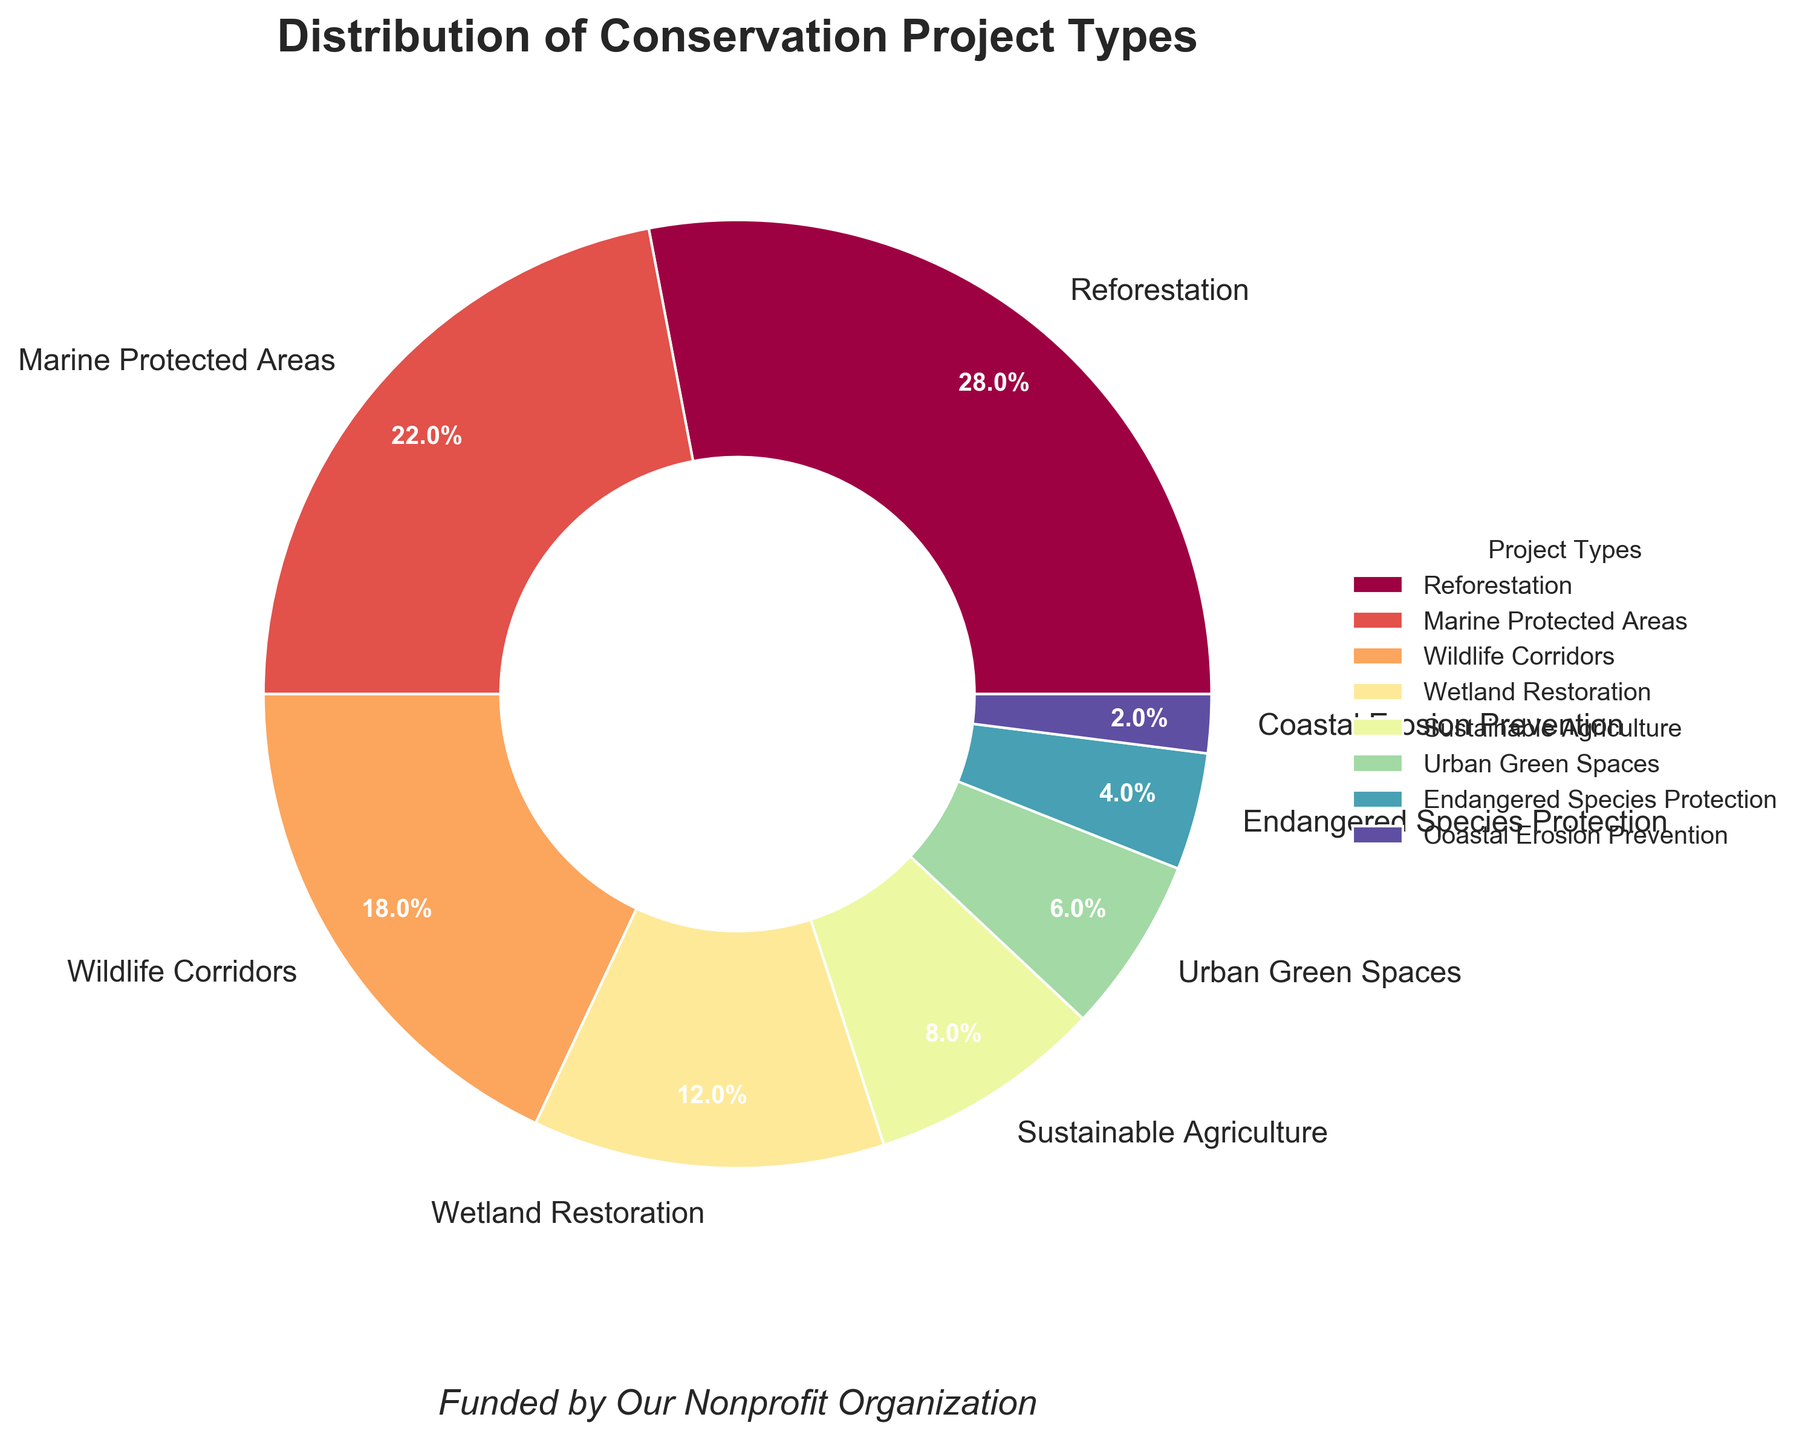What percentage of projects funded are focused on marine conservation (i.e., Marine Protected Areas and Coastal Erosion Prevention combined)? Add the percentages of Marine Protected Areas and Coastal Erosion Prevention: 22% + 2% = 24%
Answer: 24% Which project type has the lowest percentage of funding? The project type with the smallest wedge in the pie chart represents the lowest percentage, which is Coastal Erosion Prevention at 2%
Answer: Coastal Erosion Prevention How much higher is the percentage of Reforestation projects than Sustainable Agriculture projects? Subtract the percentage of Sustainable Agriculture from that of Reforestation: 28% - 8% = 20%
Answer: 20% What is the combined percentage of projects focused on land conservation (i.e., Reforestation, Wildlife Corridors, and Urban Green Spaces)? Sum the percentages: 28% (Reforestation) + 18% (Wildlife Corridors) + 6% (Urban Green Spaces) = 52%
Answer: 52% Which has a higher percentage, Wetland Restoration or Endangered Species Protection? Compare the percentages: Wetland Restoration is 12%, and Endangered Species Protection is 4%, so Wetland Restoration is higher
Answer: Wetland Restoration How much lower is the percentage of Endangered Species Protection compared to Wildlife Corridors? Subtract the percentage of Endangered Species Protection from that of Wildlife Corridors: 18% - 4% = 14%
Answer: 14% If you consider only projects related to terrestrial ecosystems (Reforestation, Wildlife Corridors, Sustainable Agriculture, Urban Green Spaces, and Endangered Species Protection), what is their average percentage? Sum the terrestrial ecosystem projects' percentages and divide by the number of projects: (28 + 18 + 8 + 6 + 4) / 5 = 64 / 5 = 12.8
Answer: 12.8% Between Wetland Restoration and Marine Protected Areas, which receives more funding and by how much? Subtract the percentage of Wetland Restoration from Marine Protected Areas: 22% - 12% = 10%
Answer: Marine Protected Areas by 10% Which two project types combined constitute exactly half of the total funding? Check each combination until you find Reforestation and Marine Protected Areas: 28% + 22% = 50%
Answer: Reforestation and Marine Protected Areas 